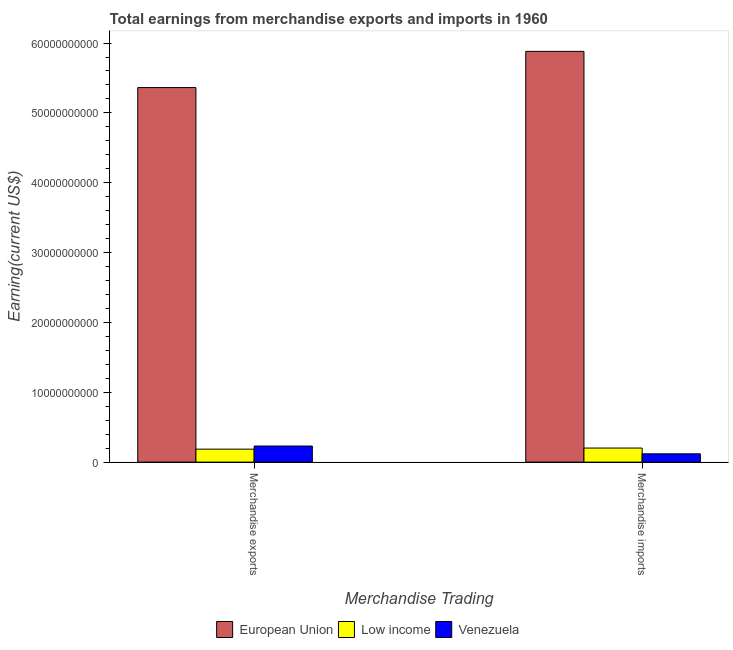How many different coloured bars are there?
Offer a terse response. 3. How many groups of bars are there?
Give a very brief answer. 2. Are the number of bars on each tick of the X-axis equal?
Offer a very short reply. Yes. How many bars are there on the 2nd tick from the left?
Keep it short and to the point. 3. What is the earnings from merchandise exports in Venezuela?
Provide a succinct answer. 2.30e+09. Across all countries, what is the maximum earnings from merchandise imports?
Provide a short and direct response. 5.88e+1. Across all countries, what is the minimum earnings from merchandise exports?
Offer a very short reply. 1.86e+09. In which country was the earnings from merchandise exports maximum?
Offer a terse response. European Union. In which country was the earnings from merchandise exports minimum?
Keep it short and to the point. Low income. What is the total earnings from merchandise imports in the graph?
Your response must be concise. 6.20e+1. What is the difference between the earnings from merchandise exports in European Union and that in Low income?
Your answer should be very brief. 5.18e+1. What is the difference between the earnings from merchandise exports in European Union and the earnings from merchandise imports in Low income?
Keep it short and to the point. 5.16e+1. What is the average earnings from merchandise exports per country?
Offer a very short reply. 1.93e+1. What is the difference between the earnings from merchandise exports and earnings from merchandise imports in Low income?
Give a very brief answer. -1.56e+08. In how many countries, is the earnings from merchandise imports greater than 58000000000 US$?
Offer a very short reply. 1. What is the ratio of the earnings from merchandise exports in European Union to that in Venezuela?
Your answer should be compact. 23.27. In how many countries, is the earnings from merchandise imports greater than the average earnings from merchandise imports taken over all countries?
Keep it short and to the point. 1. What does the 3rd bar from the left in Merchandise exports represents?
Offer a very short reply. Venezuela. What does the 1st bar from the right in Merchandise exports represents?
Your response must be concise. Venezuela. Are all the bars in the graph horizontal?
Offer a very short reply. No. How many countries are there in the graph?
Your answer should be very brief. 3. What is the difference between two consecutive major ticks on the Y-axis?
Provide a succinct answer. 1.00e+1. Does the graph contain grids?
Provide a short and direct response. No. What is the title of the graph?
Provide a succinct answer. Total earnings from merchandise exports and imports in 1960. What is the label or title of the X-axis?
Offer a terse response. Merchandise Trading. What is the label or title of the Y-axis?
Provide a short and direct response. Earning(current US$). What is the Earning(current US$) of European Union in Merchandise exports?
Keep it short and to the point. 5.36e+1. What is the Earning(current US$) of Low income in Merchandise exports?
Your answer should be very brief. 1.86e+09. What is the Earning(current US$) of Venezuela in Merchandise exports?
Offer a very short reply. 2.30e+09. What is the Earning(current US$) in European Union in Merchandise imports?
Provide a succinct answer. 5.88e+1. What is the Earning(current US$) of Low income in Merchandise imports?
Ensure brevity in your answer.  2.01e+09. What is the Earning(current US$) in Venezuela in Merchandise imports?
Make the answer very short. 1.19e+09. Across all Merchandise Trading, what is the maximum Earning(current US$) in European Union?
Your response must be concise. 5.88e+1. Across all Merchandise Trading, what is the maximum Earning(current US$) of Low income?
Provide a succinct answer. 2.01e+09. Across all Merchandise Trading, what is the maximum Earning(current US$) in Venezuela?
Your answer should be compact. 2.30e+09. Across all Merchandise Trading, what is the minimum Earning(current US$) in European Union?
Make the answer very short. 5.36e+1. Across all Merchandise Trading, what is the minimum Earning(current US$) in Low income?
Provide a succinct answer. 1.86e+09. Across all Merchandise Trading, what is the minimum Earning(current US$) of Venezuela?
Give a very brief answer. 1.19e+09. What is the total Earning(current US$) in European Union in the graph?
Offer a very short reply. 1.12e+11. What is the total Earning(current US$) of Low income in the graph?
Offer a terse response. 3.87e+09. What is the total Earning(current US$) of Venezuela in the graph?
Offer a terse response. 3.49e+09. What is the difference between the Earning(current US$) of European Union in Merchandise exports and that in Merchandise imports?
Your answer should be very brief. -5.18e+09. What is the difference between the Earning(current US$) in Low income in Merchandise exports and that in Merchandise imports?
Provide a succinct answer. -1.56e+08. What is the difference between the Earning(current US$) of Venezuela in Merchandise exports and that in Merchandise imports?
Your answer should be very brief. 1.12e+09. What is the difference between the Earning(current US$) of European Union in Merchandise exports and the Earning(current US$) of Low income in Merchandise imports?
Ensure brevity in your answer.  5.16e+1. What is the difference between the Earning(current US$) in European Union in Merchandise exports and the Earning(current US$) in Venezuela in Merchandise imports?
Offer a very short reply. 5.24e+1. What is the difference between the Earning(current US$) of Low income in Merchandise exports and the Earning(current US$) of Venezuela in Merchandise imports?
Keep it short and to the point. 6.70e+08. What is the average Earning(current US$) of European Union per Merchandise Trading?
Keep it short and to the point. 5.62e+1. What is the average Earning(current US$) of Low income per Merchandise Trading?
Keep it short and to the point. 1.94e+09. What is the average Earning(current US$) in Venezuela per Merchandise Trading?
Provide a short and direct response. 1.75e+09. What is the difference between the Earning(current US$) of European Union and Earning(current US$) of Low income in Merchandise exports?
Give a very brief answer. 5.18e+1. What is the difference between the Earning(current US$) of European Union and Earning(current US$) of Venezuela in Merchandise exports?
Make the answer very short. 5.13e+1. What is the difference between the Earning(current US$) of Low income and Earning(current US$) of Venezuela in Merchandise exports?
Provide a short and direct response. -4.47e+08. What is the difference between the Earning(current US$) in European Union and Earning(current US$) in Low income in Merchandise imports?
Provide a short and direct response. 5.68e+1. What is the difference between the Earning(current US$) of European Union and Earning(current US$) of Venezuela in Merchandise imports?
Your answer should be compact. 5.76e+1. What is the difference between the Earning(current US$) in Low income and Earning(current US$) in Venezuela in Merchandise imports?
Offer a very short reply. 8.26e+08. What is the ratio of the Earning(current US$) of European Union in Merchandise exports to that in Merchandise imports?
Ensure brevity in your answer.  0.91. What is the ratio of the Earning(current US$) of Low income in Merchandise exports to that in Merchandise imports?
Provide a succinct answer. 0.92. What is the ratio of the Earning(current US$) in Venezuela in Merchandise exports to that in Merchandise imports?
Give a very brief answer. 1.94. What is the difference between the highest and the second highest Earning(current US$) in European Union?
Give a very brief answer. 5.18e+09. What is the difference between the highest and the second highest Earning(current US$) of Low income?
Your answer should be very brief. 1.56e+08. What is the difference between the highest and the second highest Earning(current US$) in Venezuela?
Your answer should be very brief. 1.12e+09. What is the difference between the highest and the lowest Earning(current US$) of European Union?
Provide a short and direct response. 5.18e+09. What is the difference between the highest and the lowest Earning(current US$) of Low income?
Make the answer very short. 1.56e+08. What is the difference between the highest and the lowest Earning(current US$) of Venezuela?
Provide a short and direct response. 1.12e+09. 